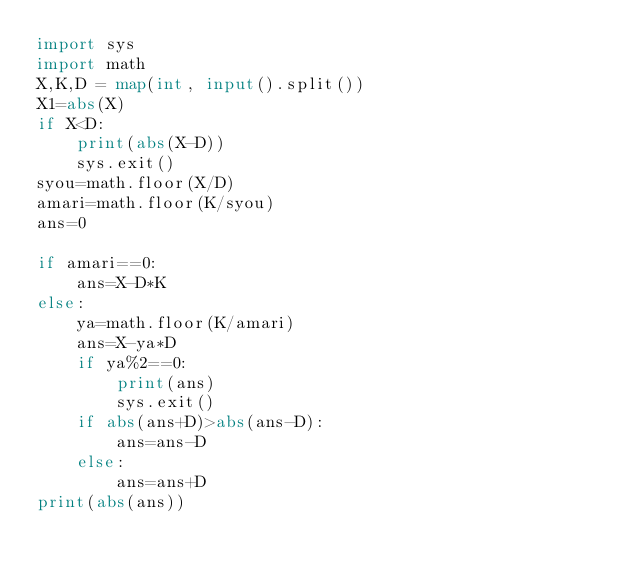<code> <loc_0><loc_0><loc_500><loc_500><_Python_>import sys
import math
X,K,D = map(int, input().split()) 
X1=abs(X)
if X<D:
    print(abs(X-D))
    sys.exit()
syou=math.floor(X/D)
amari=math.floor(K/syou)
ans=0

if amari==0:
    ans=X-D*K
else:
    ya=math.floor(K/amari)
    ans=X-ya*D
    if ya%2==0:
        print(ans)
        sys.exit()
    if abs(ans+D)>abs(ans-D):
        ans=ans-D
    else:
        ans=ans+D
print(abs(ans))</code> 